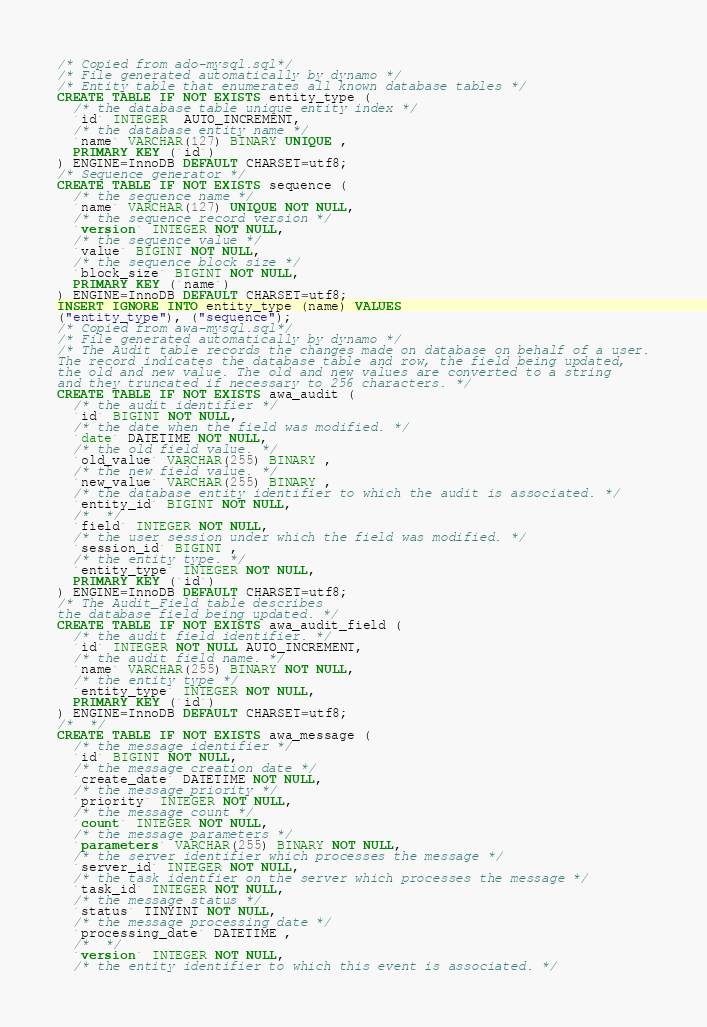Convert code to text. <code><loc_0><loc_0><loc_500><loc_500><_SQL_>/* Copied from ado-mysql.sql*/
/* File generated automatically by dynamo */
/* Entity table that enumerates all known database tables */
CREATE TABLE IF NOT EXISTS entity_type (
  /* the database table unique entity index */
  `id` INTEGER  AUTO_INCREMENT,
  /* the database entity name */
  `name` VARCHAR(127) BINARY UNIQUE ,
  PRIMARY KEY (`id`)
) ENGINE=InnoDB DEFAULT CHARSET=utf8;
/* Sequence generator */
CREATE TABLE IF NOT EXISTS sequence (
  /* the sequence name */
  `name` VARCHAR(127) UNIQUE NOT NULL,
  /* the sequence record version */
  `version` INTEGER NOT NULL,
  /* the sequence value */
  `value` BIGINT NOT NULL,
  /* the sequence block size */
  `block_size` BIGINT NOT NULL,
  PRIMARY KEY (`name`)
) ENGINE=InnoDB DEFAULT CHARSET=utf8;
INSERT IGNORE INTO entity_type (name) VALUES
("entity_type"), ("sequence");
/* Copied from awa-mysql.sql*/
/* File generated automatically by dynamo */
/* The Audit table records the changes made on database on behalf of a user.
The record indicates the database table and row, the field being updated,
the old and new value. The old and new values are converted to a string
and they truncated if necessary to 256 characters. */
CREATE TABLE IF NOT EXISTS awa_audit (
  /* the audit identifier */
  `id` BIGINT NOT NULL,
  /* the date when the field was modified. */
  `date` DATETIME NOT NULL,
  /* the old field value. */
  `old_value` VARCHAR(255) BINARY ,
  /* the new field value. */
  `new_value` VARCHAR(255) BINARY ,
  /* the database entity identifier to which the audit is associated. */
  `entity_id` BIGINT NOT NULL,
  /*  */
  `field` INTEGER NOT NULL,
  /* the user session under which the field was modified. */
  `session_id` BIGINT ,
  /* the entity type. */
  `entity_type` INTEGER NOT NULL,
  PRIMARY KEY (`id`)
) ENGINE=InnoDB DEFAULT CHARSET=utf8;
/* The Audit_Field table describes
the database field being updated. */
CREATE TABLE IF NOT EXISTS awa_audit_field (
  /* the audit field identifier. */
  `id` INTEGER NOT NULL AUTO_INCREMENT,
  /* the audit field name. */
  `name` VARCHAR(255) BINARY NOT NULL,
  /* the entity type */
  `entity_type` INTEGER NOT NULL,
  PRIMARY KEY (`id`)
) ENGINE=InnoDB DEFAULT CHARSET=utf8;
/*  */
CREATE TABLE IF NOT EXISTS awa_message (
  /* the message identifier */
  `id` BIGINT NOT NULL,
  /* the message creation date */
  `create_date` DATETIME NOT NULL,
  /* the message priority */
  `priority` INTEGER NOT NULL,
  /* the message count */
  `count` INTEGER NOT NULL,
  /* the message parameters */
  `parameters` VARCHAR(255) BINARY NOT NULL,
  /* the server identifier which processes the message */
  `server_id` INTEGER NOT NULL,
  /* the task identfier on the server which processes the message */
  `task_id` INTEGER NOT NULL,
  /* the message status */
  `status` TINYINT NOT NULL,
  /* the message processing date */
  `processing_date` DATETIME ,
  /*  */
  `version` INTEGER NOT NULL,
  /* the entity identifier to which this event is associated. */</code> 